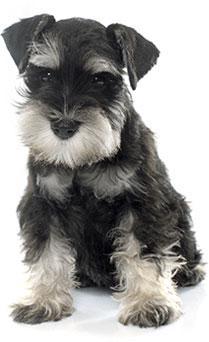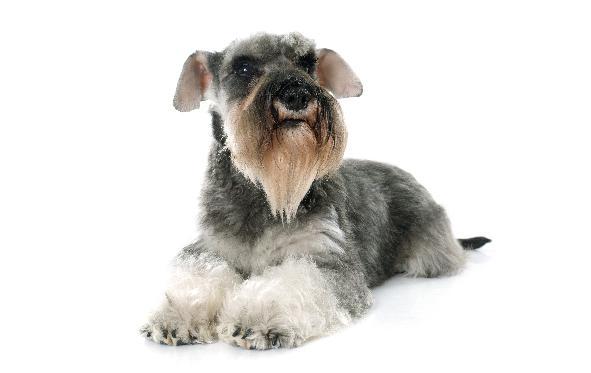The first image is the image on the left, the second image is the image on the right. For the images displayed, is the sentence "An image shows a standing schnauzer dog posed with dog food." factually correct? Answer yes or no. No. The first image is the image on the left, the second image is the image on the right. Examine the images to the left and right. Is the description "The dogs are facing generally in the opposite direction" accurate? Answer yes or no. No. 